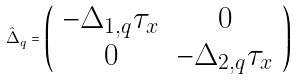<formula> <loc_0><loc_0><loc_500><loc_500>\hat { \Delta } _ { q } = \left ( \begin{array} { c c } - \Delta _ { 1 , q } \tau _ { x } & 0 \\ 0 & - \Delta _ { 2 , q } \tau _ { x } \end{array} \right )</formula> 